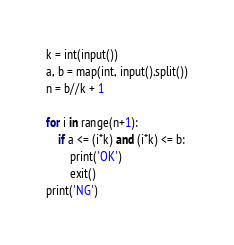<code> <loc_0><loc_0><loc_500><loc_500><_Python_>k = int(input())
a, b = map(int, input().split())
n = b//k + 1

for i in range(n+1):
    if a <= (i*k) and (i*k) <= b:
        print('OK')
        exit()
print('NG')</code> 